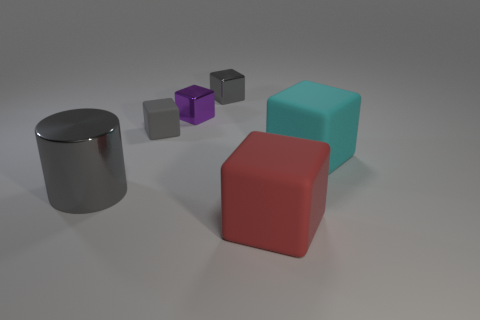Can you describe the differences between the objects on the left and those on the right? The objects on the left, including a shiny gray cylinder and two smaller blocks, one purple and one gray, have more metallic and reflective surfaces, suggesting they might be made of metal. The objects on the right, consisting of a teal cube and a red cuboid, have more matte surfaces which could indicate a plastic or painted material. 